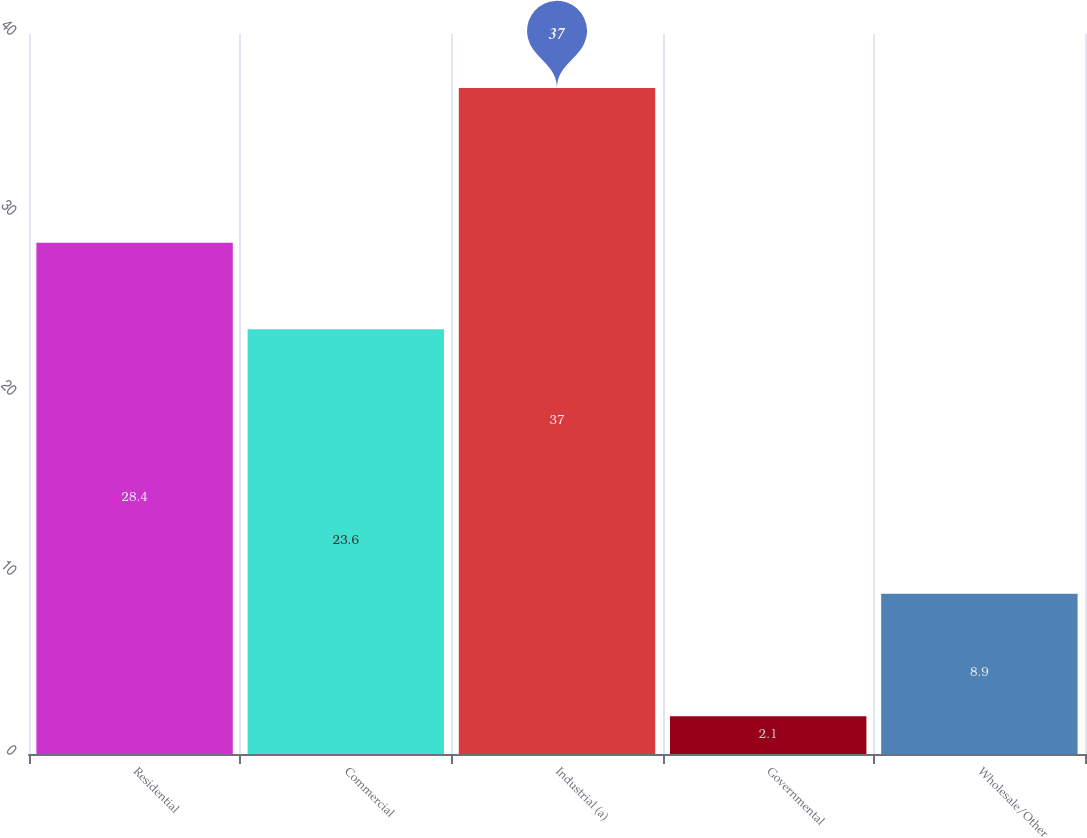Convert chart. <chart><loc_0><loc_0><loc_500><loc_500><bar_chart><fcel>Residential<fcel>Commercial<fcel>Industrial (a)<fcel>Governmental<fcel>Wholesale/Other<nl><fcel>28.4<fcel>23.6<fcel>37<fcel>2.1<fcel>8.9<nl></chart> 